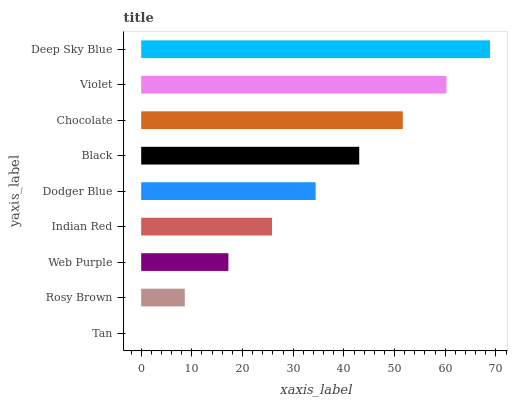Is Tan the minimum?
Answer yes or no. Yes. Is Deep Sky Blue the maximum?
Answer yes or no. Yes. Is Rosy Brown the minimum?
Answer yes or no. No. Is Rosy Brown the maximum?
Answer yes or no. No. Is Rosy Brown greater than Tan?
Answer yes or no. Yes. Is Tan less than Rosy Brown?
Answer yes or no. Yes. Is Tan greater than Rosy Brown?
Answer yes or no. No. Is Rosy Brown less than Tan?
Answer yes or no. No. Is Dodger Blue the high median?
Answer yes or no. Yes. Is Dodger Blue the low median?
Answer yes or no. Yes. Is Violet the high median?
Answer yes or no. No. Is Black the low median?
Answer yes or no. No. 